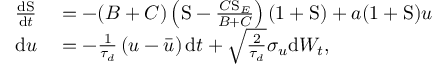<formula> <loc_0><loc_0><loc_500><loc_500>\begin{array} { r l } { \frac { d S } { d t } } & = - ( B + C ) \left ( S - \frac { C S _ { E } } { B + C } \right ) ( 1 + S ) + a ( 1 + S ) u } \\ { d u } & = - \frac { 1 } { \tau _ { d } } \left ( u - \bar { u } \right ) d t + \sqrt { \frac { 2 } { \tau _ { d } } } \sigma _ { u } d W _ { t } , } \end{array}</formula> 